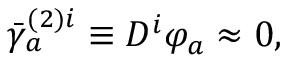Convert formula to latex. <formula><loc_0><loc_0><loc_500><loc_500>\bar { \gamma } _ { a } ^ { ( 2 ) i } \equiv D ^ { i } \varphi _ { a } \approx 0 ,</formula> 